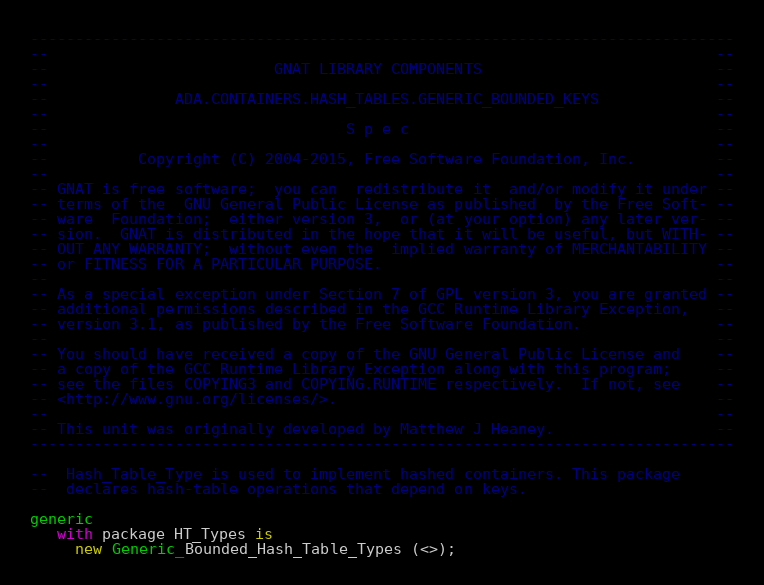Convert code to text. <code><loc_0><loc_0><loc_500><loc_500><_Ada_>------------------------------------------------------------------------------
--                                                                          --
--                         GNAT LIBRARY COMPONENTS                          --
--                                                                          --
--              ADA.CONTAINERS.HASH_TABLES.GENERIC_BOUNDED_KEYS             --
--                                                                          --
--                                 S p e c                                  --
--                                                                          --
--          Copyright (C) 2004-2015, Free Software Foundation, Inc.         --
--                                                                          --
-- GNAT is free software;  you can  redistribute it  and/or modify it under --
-- terms of the  GNU General Public License as published  by the Free Soft- --
-- ware  Foundation;  either version 3,  or (at your option) any later ver- --
-- sion.  GNAT is distributed in the hope that it will be useful, but WITH- --
-- OUT ANY WARRANTY;  without even the  implied warranty of MERCHANTABILITY --
-- or FITNESS FOR A PARTICULAR PURPOSE.                                     --
--                                                                          --
-- As a special exception under Section 7 of GPL version 3, you are granted --
-- additional permissions described in the GCC Runtime Library Exception,   --
-- version 3.1, as published by the Free Software Foundation.               --
--                                                                          --
-- You should have received a copy of the GNU General Public License and    --
-- a copy of the GCC Runtime Library Exception along with this program;     --
-- see the files COPYING3 and COPYING.RUNTIME respectively.  If not, see    --
-- <http://www.gnu.org/licenses/>.                                          --
--                                                                          --
-- This unit was originally developed by Matthew J Heaney.                  --
------------------------------------------------------------------------------

--  Hash_Table_Type is used to implement hashed containers. This package
--  declares hash-table operations that depend on keys.

generic
   with package HT_Types is
     new Generic_Bounded_Hash_Table_Types (<>);
</code> 